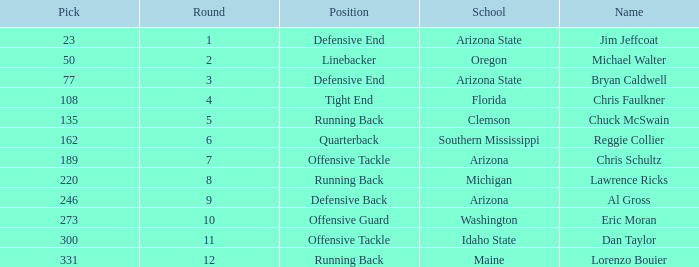What is the number of the pick for round 11? 300.0. 